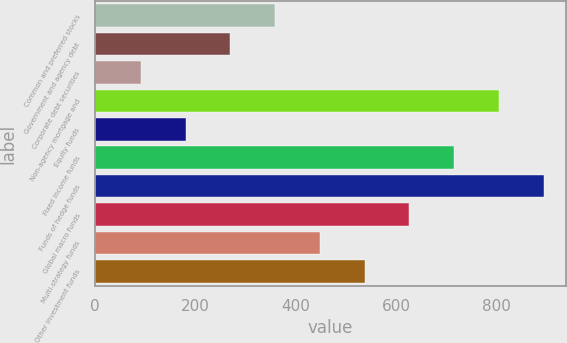Convert chart. <chart><loc_0><loc_0><loc_500><loc_500><bar_chart><fcel>Common and preferred stocks<fcel>Government and agency debt<fcel>Corporate debt securities<fcel>Non-agency mortgage and<fcel>Equity funds<fcel>Fixed income funds<fcel>Funds of hedge funds<fcel>Global macro funds<fcel>Multi-strategy funds<fcel>Other investment funds<nl><fcel>359.4<fcel>270.3<fcel>92.1<fcel>804.9<fcel>181.2<fcel>715.8<fcel>894<fcel>626.7<fcel>448.5<fcel>537.6<nl></chart> 